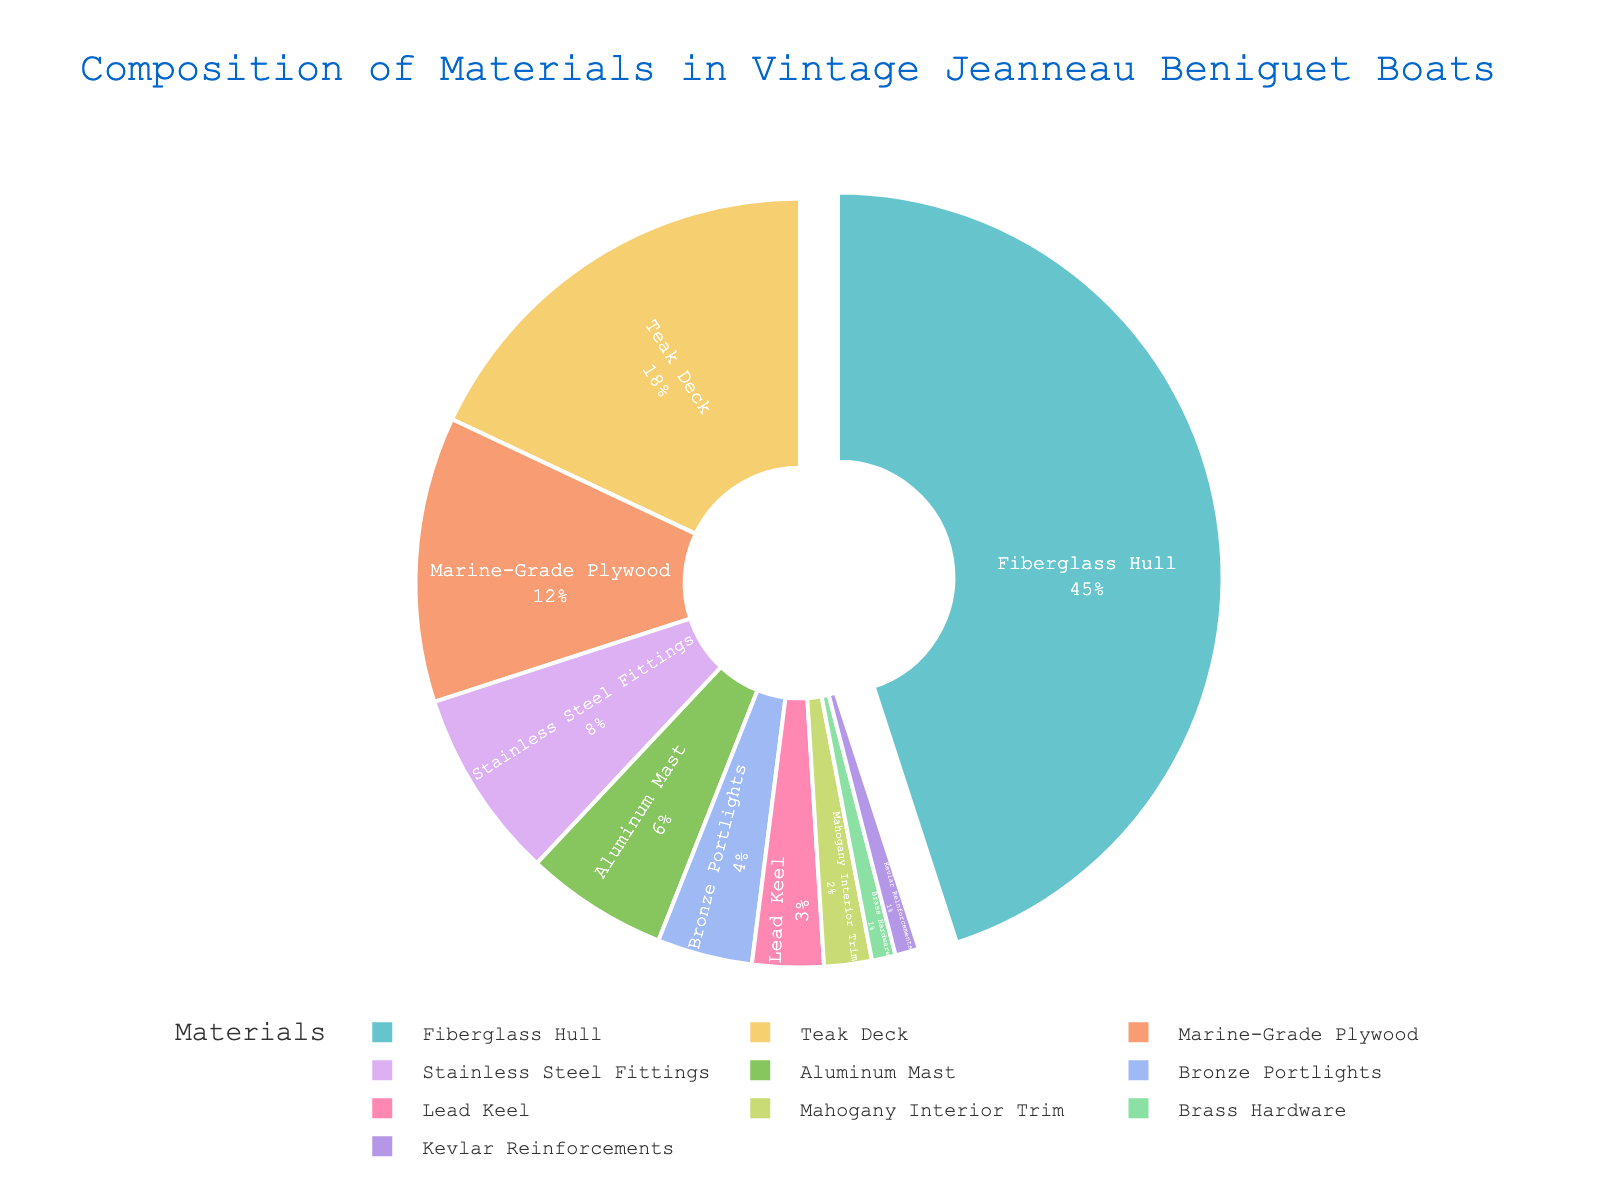What are the top three materials used in the construction of vintage Jeanneau Beniguet boats? The top three materials can be identified by looking at the segments with the three highest percentages. These are Fiberglass Hull (45%), Teak Deck (18%), and Marine-Grade Plywood (12%).
Answer: Fiberglass Hull, Teak Deck, Marine-Grade Plywood Which material has a higher percentage, Aluminum Mast or Stainless Steel Fittings? By comparing the percentages shown for Aluminum Mast (6%) and Stainless Steel Fittings (8%), we see that Stainless Steel Fittings has a higher percentage.
Answer: Stainless Steel Fittings What is the total percentage composition of wood components (Teak Deck, Marine-Grade Plywood, and Mahogany Interior Trim)? To find the total percentage of wood components, we sum the percentages: Teak Deck (18%) + Marine-Grade Plywood (12%) + Mahogany Interior Trim (2%) = 32%.
Answer: 32% How does the percentage of Lead Keel compare to the percentage of Bronze Portlights? The percentage of Lead Keel (3%) needs to be compared to Bronze Portlights (4%). Since 3% is less than 4%, the conclusion is that Lead Keel has a smaller percentage.
Answer: Lead Keel is less If you combine the percentages of the least used materials (Mahogany Interior Trim, Brass Hardware, and Kevlar Reinforcements), do they sum up to more or less than 5%? Adding the percentages of Mahogany Interior Trim (2%), Brass Hardware (1%), and Kevlar Reinforcements (1%) gives us 2% + 1% + 1% = 4%. This is less than 5%.
Answer: Less What is the percentage difference between the Fiberglass Hull and the combined total of wood components? First, calculate the combined total of wood components: Teak Deck (18%) + Marine-Grade Plywood (12%) + Mahogany Interior Trim (2%) = 32%. Then, subtract this from Fiberglass Hull (45%): 45% - 32% = 13%.
Answer: 13% Identify the material represented by the smallest segment in the pie chart. The smallest segment can be identified by looking at the material with the lowest percentage, which is Brass Hardware (1%).
Answer: Brass Hardware Which segment appears larger, Marine-Grade Plywood or Aluminum Mast? By visually comparing the sections, Marine-Grade Plywood (12%) is visibly larger than Aluminum Mast (6%).
Answer: Marine-Grade Plywood How much more percentage does Fiberglass Hull have compared to the sum of Stainless Steel Fittings and Bronze Portlights? Adding Stainless Steel Fittings (8%) and Bronze Portlights (4%) gives 12%. Then, the difference from Fiberglass Hull (45%) is 45% - 12% = 33%.
Answer: 33% What percentage of materials used is metal (Stainless Steel Fittings, Aluminum Mast, Bronze Portlights, Brass Hardware, Lead Keel)? Summing the metal components: Stainless Steel Fittings (8%) + Aluminum Mast (6%) + Bronze Portlights (4%) + Brass Hardware (1%) + Lead Keel (3%) = 22%.
Answer: 22% 